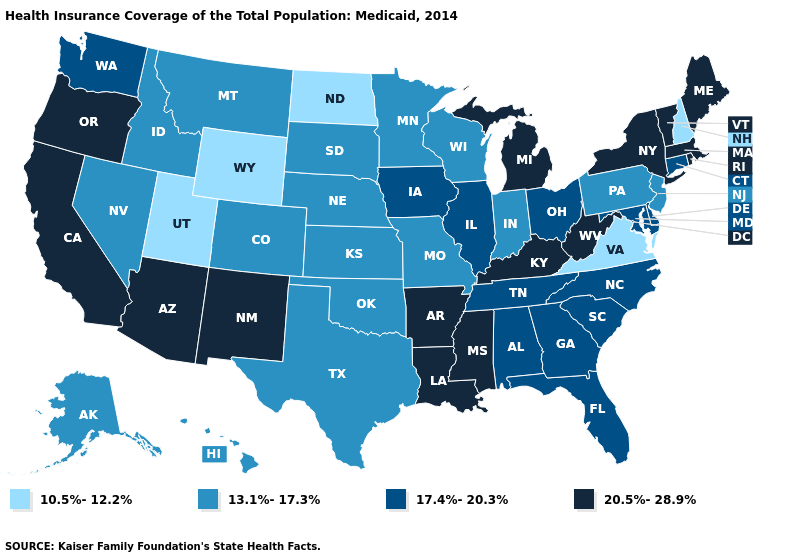Does the map have missing data?
Answer briefly. No. Among the states that border Arizona , which have the highest value?
Short answer required. California, New Mexico. Does Alabama have the same value as New Hampshire?
Quick response, please. No. What is the highest value in the South ?
Give a very brief answer. 20.5%-28.9%. Is the legend a continuous bar?
Write a very short answer. No. What is the value of California?
Concise answer only. 20.5%-28.9%. What is the value of Washington?
Short answer required. 17.4%-20.3%. Which states have the lowest value in the MidWest?
Give a very brief answer. North Dakota. Among the states that border Tennessee , which have the lowest value?
Write a very short answer. Virginia. What is the value of Wyoming?
Give a very brief answer. 10.5%-12.2%. What is the value of Minnesota?
Concise answer only. 13.1%-17.3%. Name the states that have a value in the range 17.4%-20.3%?
Short answer required. Alabama, Connecticut, Delaware, Florida, Georgia, Illinois, Iowa, Maryland, North Carolina, Ohio, South Carolina, Tennessee, Washington. Does Illinois have the same value as New York?
Concise answer only. No. Does North Dakota have the lowest value in the USA?
Give a very brief answer. Yes. What is the lowest value in states that border Minnesota?
Quick response, please. 10.5%-12.2%. 